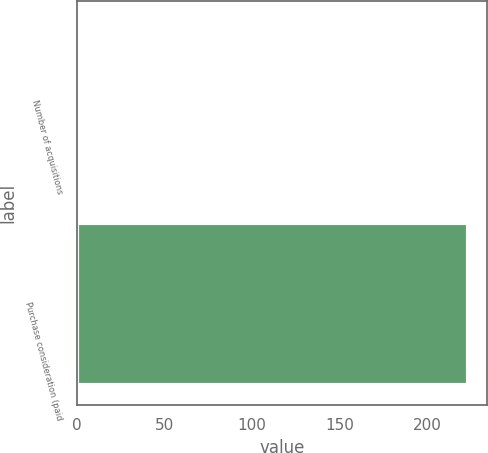<chart> <loc_0><loc_0><loc_500><loc_500><bar_chart><fcel>Number of acquisitions<fcel>Purchase consideration (paid<nl><fcel>2<fcel>223<nl></chart> 